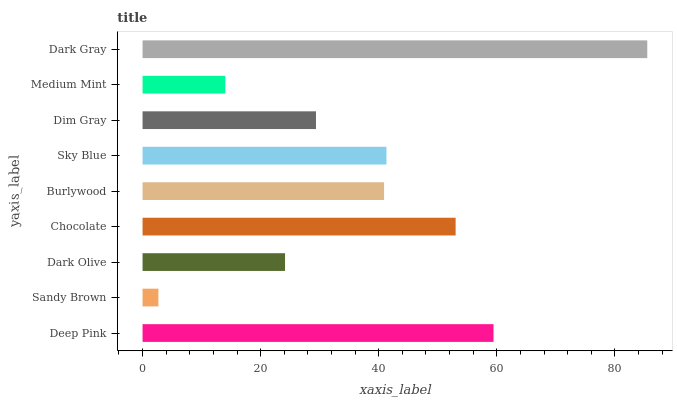Is Sandy Brown the minimum?
Answer yes or no. Yes. Is Dark Gray the maximum?
Answer yes or no. Yes. Is Dark Olive the minimum?
Answer yes or no. No. Is Dark Olive the maximum?
Answer yes or no. No. Is Dark Olive greater than Sandy Brown?
Answer yes or no. Yes. Is Sandy Brown less than Dark Olive?
Answer yes or no. Yes. Is Sandy Brown greater than Dark Olive?
Answer yes or no. No. Is Dark Olive less than Sandy Brown?
Answer yes or no. No. Is Burlywood the high median?
Answer yes or no. Yes. Is Burlywood the low median?
Answer yes or no. Yes. Is Sandy Brown the high median?
Answer yes or no. No. Is Sandy Brown the low median?
Answer yes or no. No. 